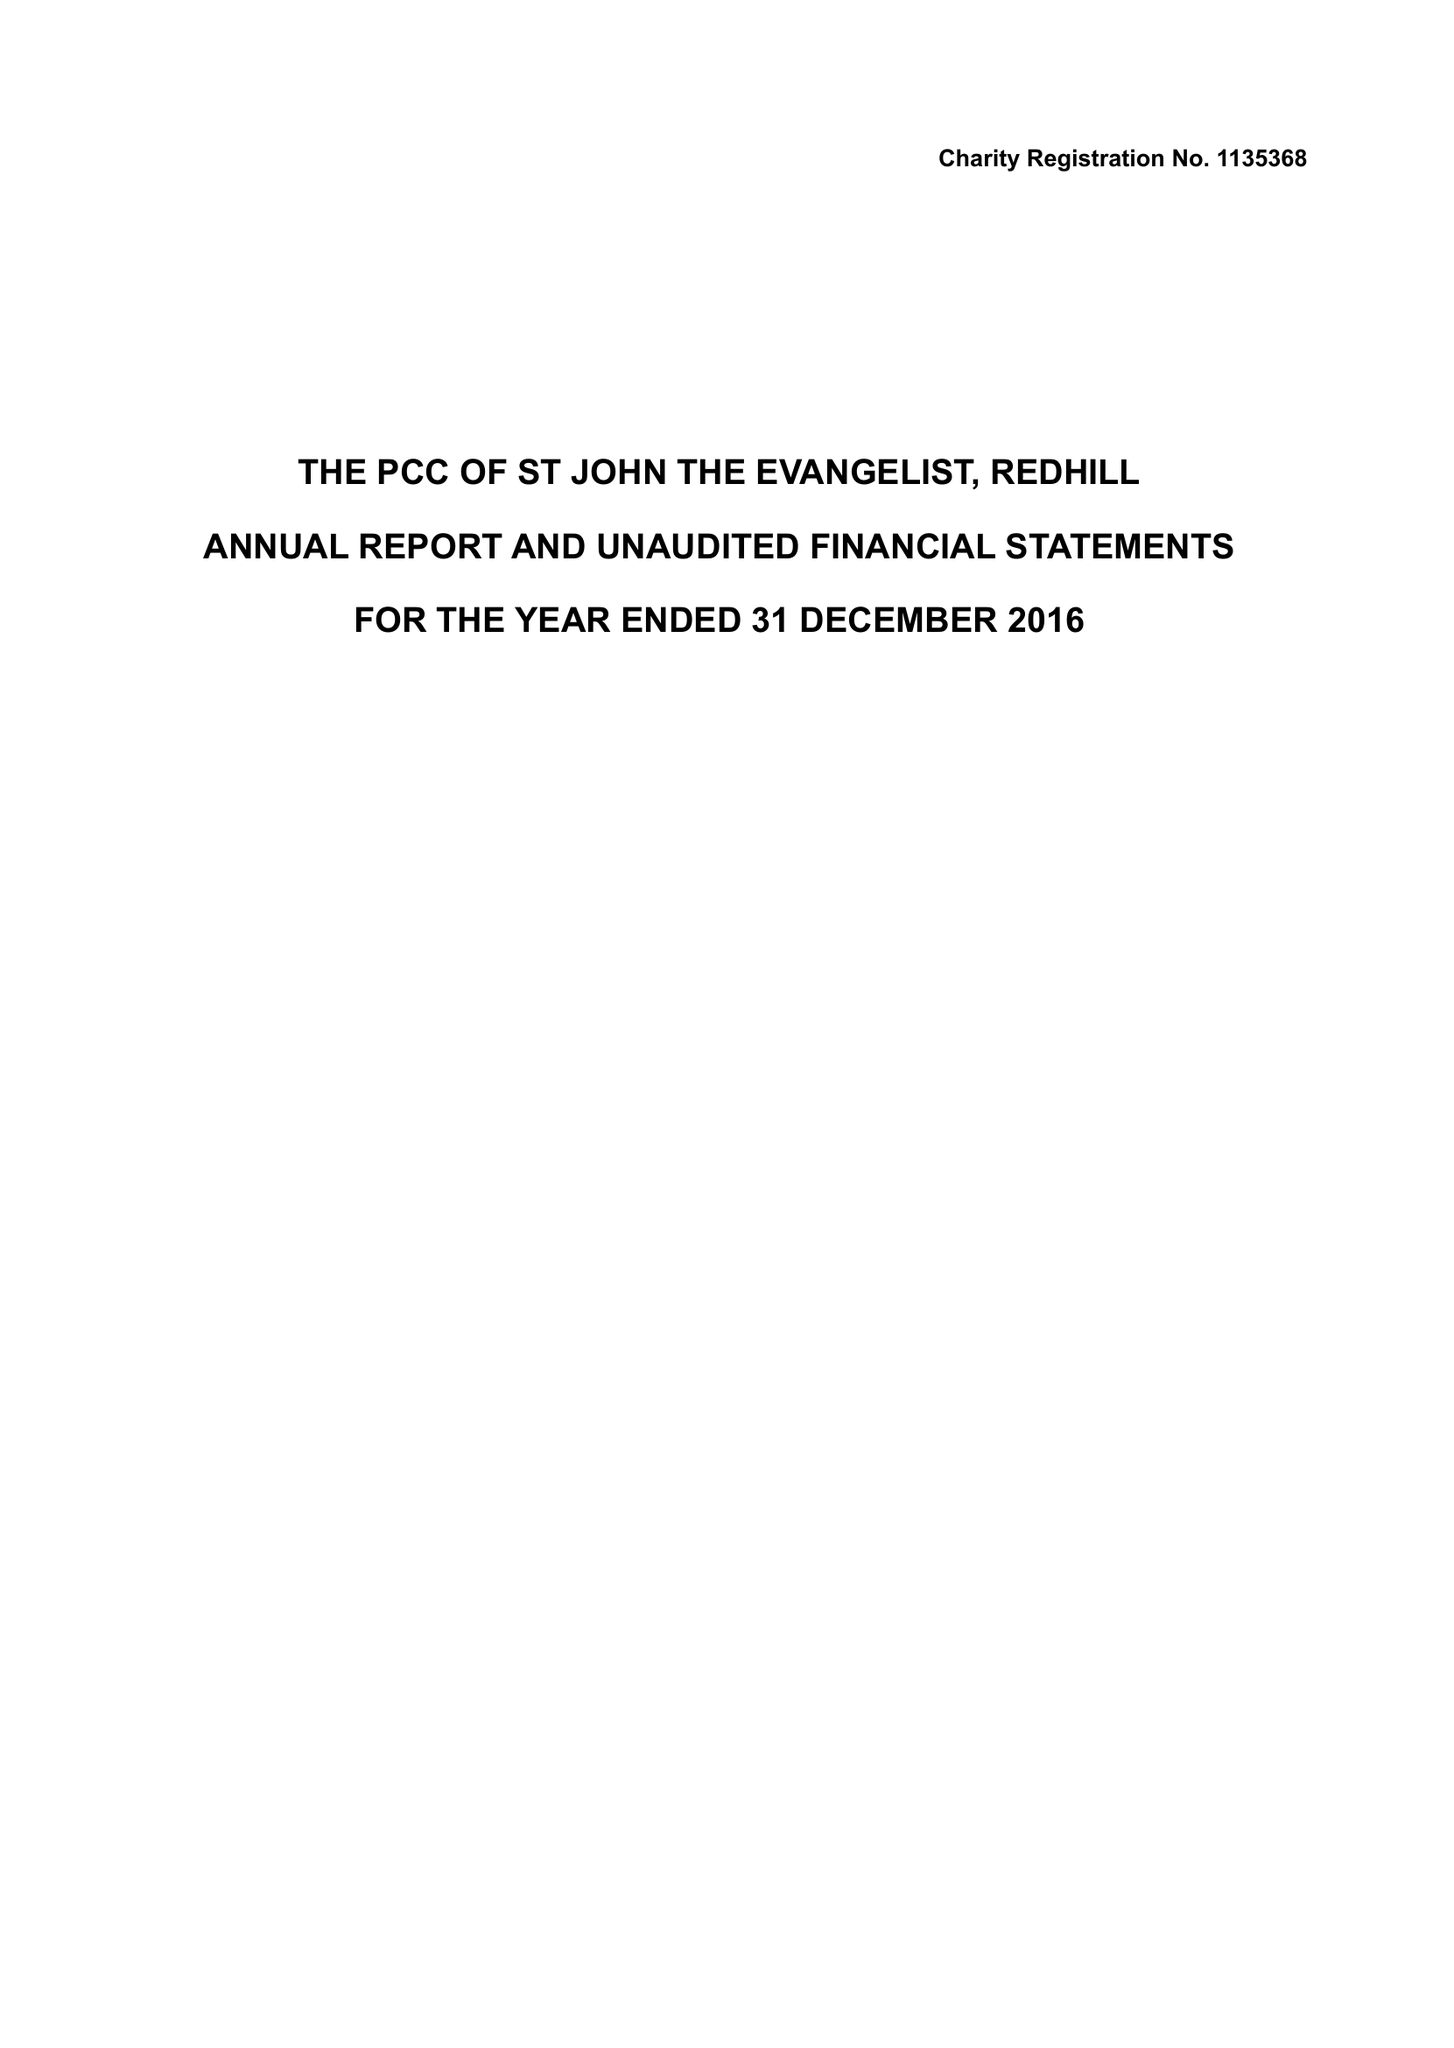What is the value for the charity_name?
Answer the question using a single word or phrase. The Parochial Church Council Of The Ecclesiastical Parish Of St John The Evangelist, Redhill 